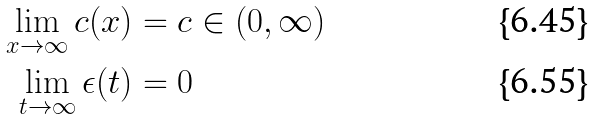<formula> <loc_0><loc_0><loc_500><loc_500>\lim _ { x \to \infty } c ( x ) & = c \in ( 0 , \infty ) \\ \lim _ { t \to \infty } \epsilon ( t ) & = 0</formula> 